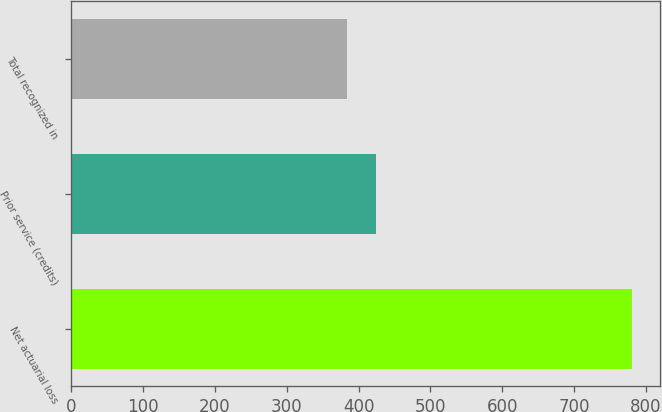<chart> <loc_0><loc_0><loc_500><loc_500><bar_chart><fcel>Net actuarial loss<fcel>Prior service (credits)<fcel>Total recognized in<nl><fcel>781<fcel>423.7<fcel>384<nl></chart> 